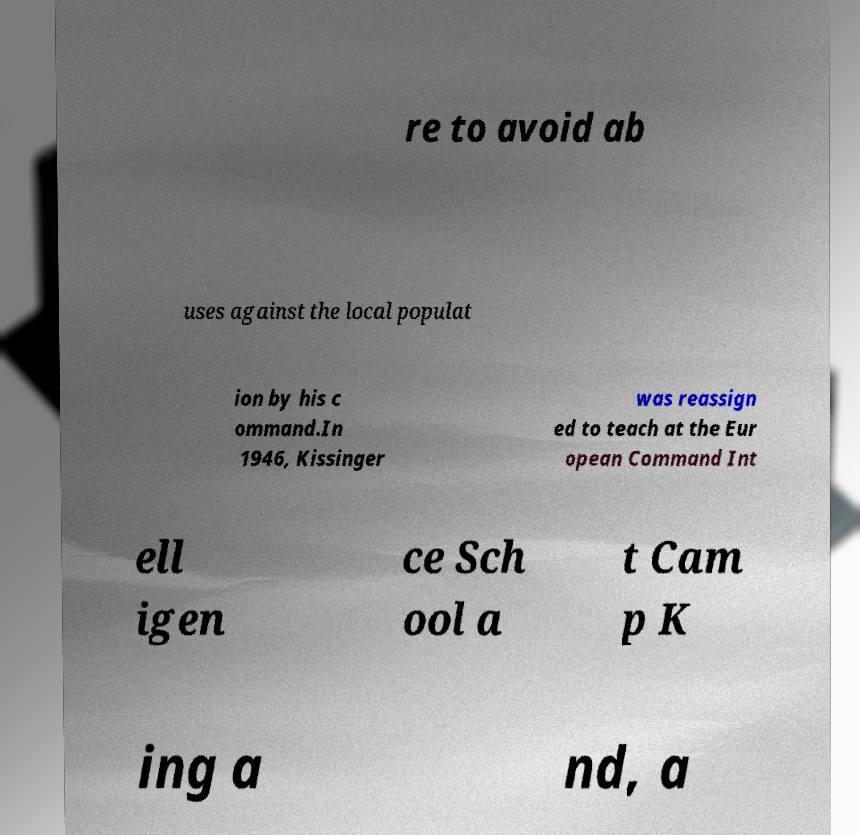There's text embedded in this image that I need extracted. Can you transcribe it verbatim? re to avoid ab uses against the local populat ion by his c ommand.In 1946, Kissinger was reassign ed to teach at the Eur opean Command Int ell igen ce Sch ool a t Cam p K ing a nd, a 